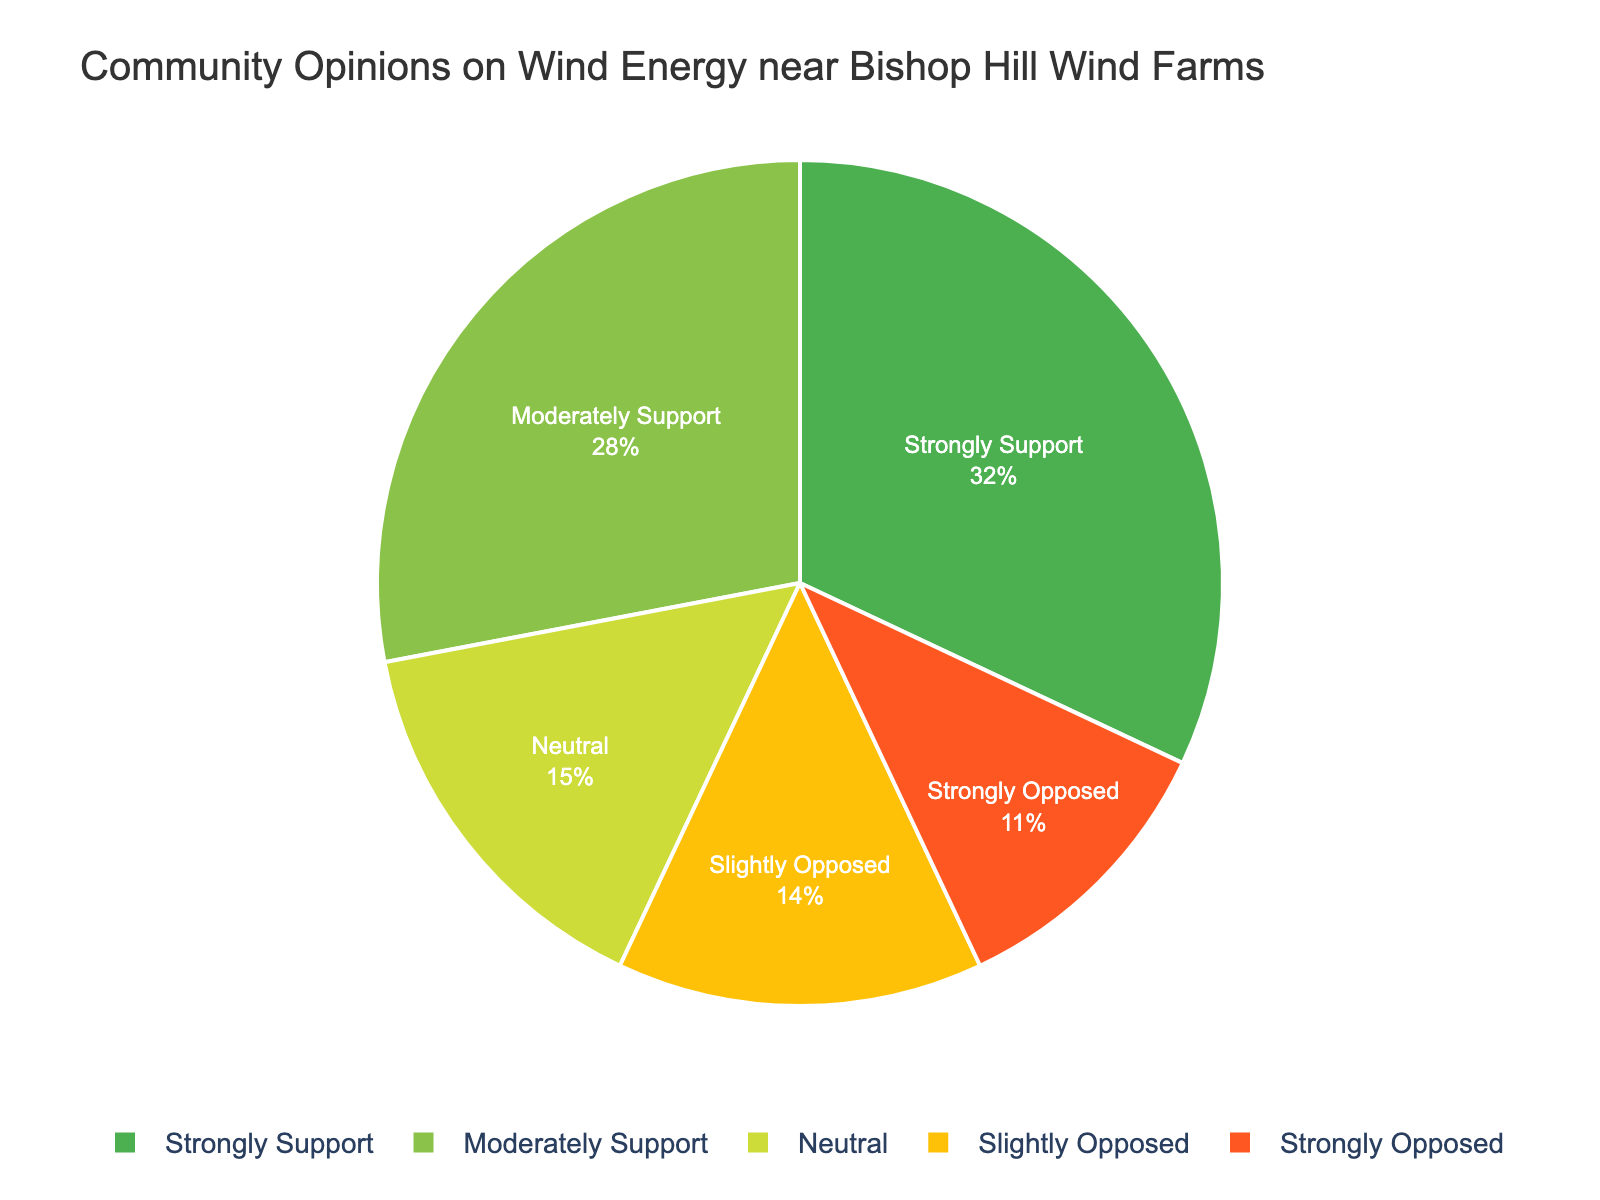Which opinion category has the highest percentage? We look at the pie chart and identify the largest section, which represents the category "Strongly Support" at 32%.
Answer: Strongly Support What's the combined percentage of people who support wind energy (both strongly and moderately)? We add the percentages for "Strongly Support" (32%) and "Moderately Support" (28%). 32% + 28% = 60%.
Answer: 60% How much higher is the percentage of people who are neutral compared to those slightly opposed? We subtract the percentage of "Slightly Opposed" (14%) from "Neutral" (15%). 15% - 14% = 1%.
Answer: 1% Which opinion category has the smallest percentage? We look at the pie chart to find the smallest section, which represents the category "Strongly Opposed" at 11%.
Answer: Strongly Opposed How does the percentage of those moderately supporting wind energy compare to the percentage of those strongly opposing it? We compare "Moderately Support" at 28% to "Strongly Opposed" at 11%. 28% is greater than 11%.
Answer: Moderately Support is higher What is the average percentage of people in the opposing categories (slightly and strongly opposed)? We add the percentages for "Slightly Opposed" (14%) and "Strongly Opposed" (11%) and divide by 2. (14% + 11%) / 2 = 12.5%.
Answer: 12.5% If we combine the neutral and slightly opposed groups, what percentage of the community do they make up? We add the percentages for "Neutral" (15%) and "Slightly Opposed" (14%). 15% + 14% = 29%.
Answer: 29% Which color represents the "Moderately Support" category in the pie chart? We review the color legend in the chart and see that "Moderately Support" is represented by a lighter green color.
Answer: Light green By how many percentage points does the "Strongly Support" category exceed the "Neutral" group? We subtract the percentage of "Neutral" (15%) from "Strongly Support" (32%). 32% - 15% = 17%.
Answer: 17% What is the total percentage of people who do not support wind energy (slightly and strongly opposed)? We add the percentages for "Slightly Opposed" (14%) and "Strongly Opposed" (11%). 14% + 11% = 25%.
Answer: 25% 